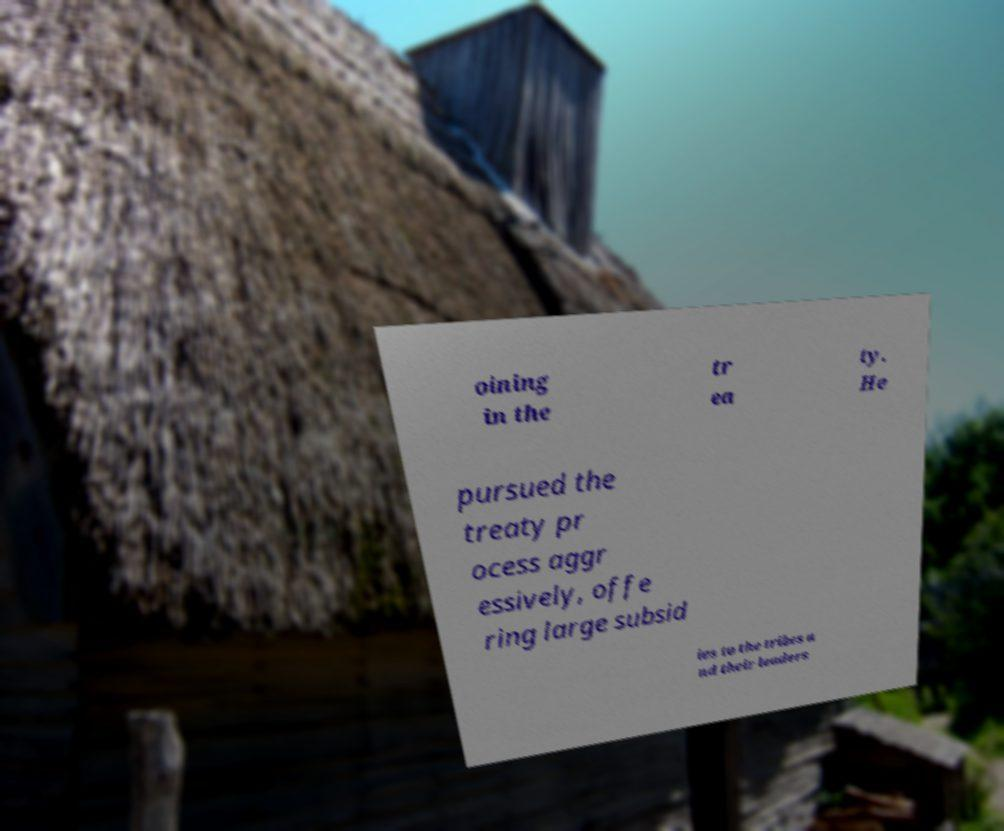Can you read and provide the text displayed in the image?This photo seems to have some interesting text. Can you extract and type it out for me? oining in the tr ea ty. He pursued the treaty pr ocess aggr essively, offe ring large subsid ies to the tribes a nd their leaders 